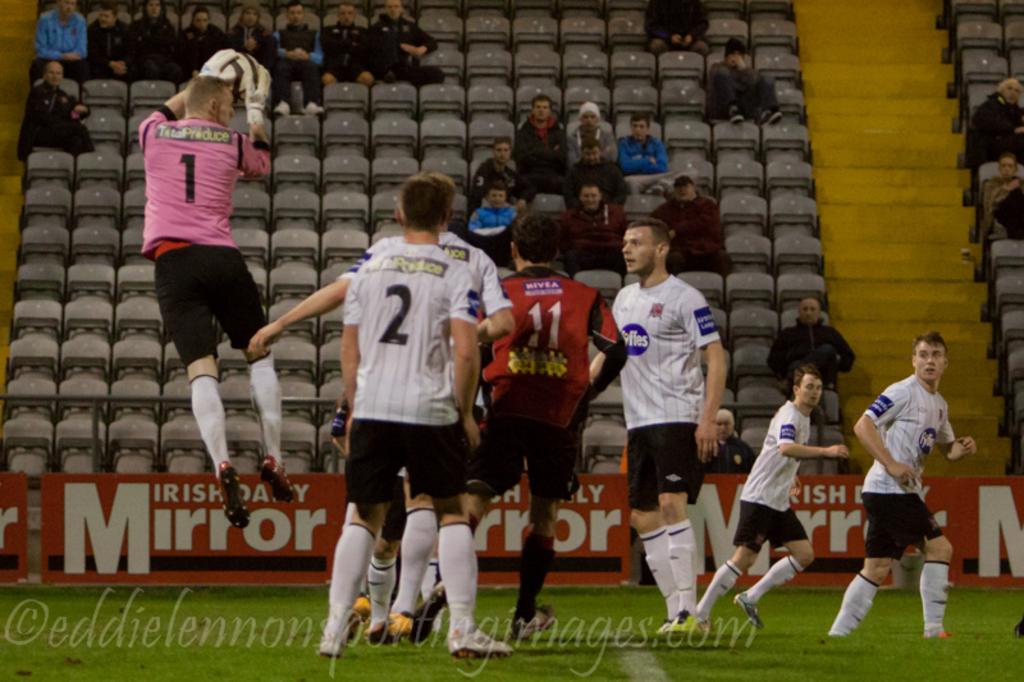What number is the man in pink?
Provide a short and direct response. 1. What player number is the person in white?
Provide a short and direct response. 2. 